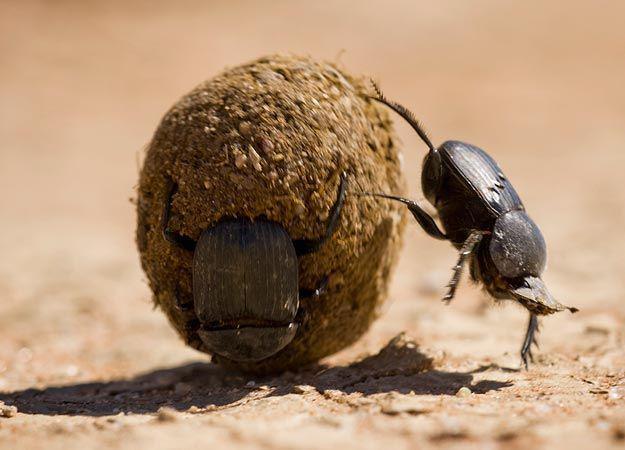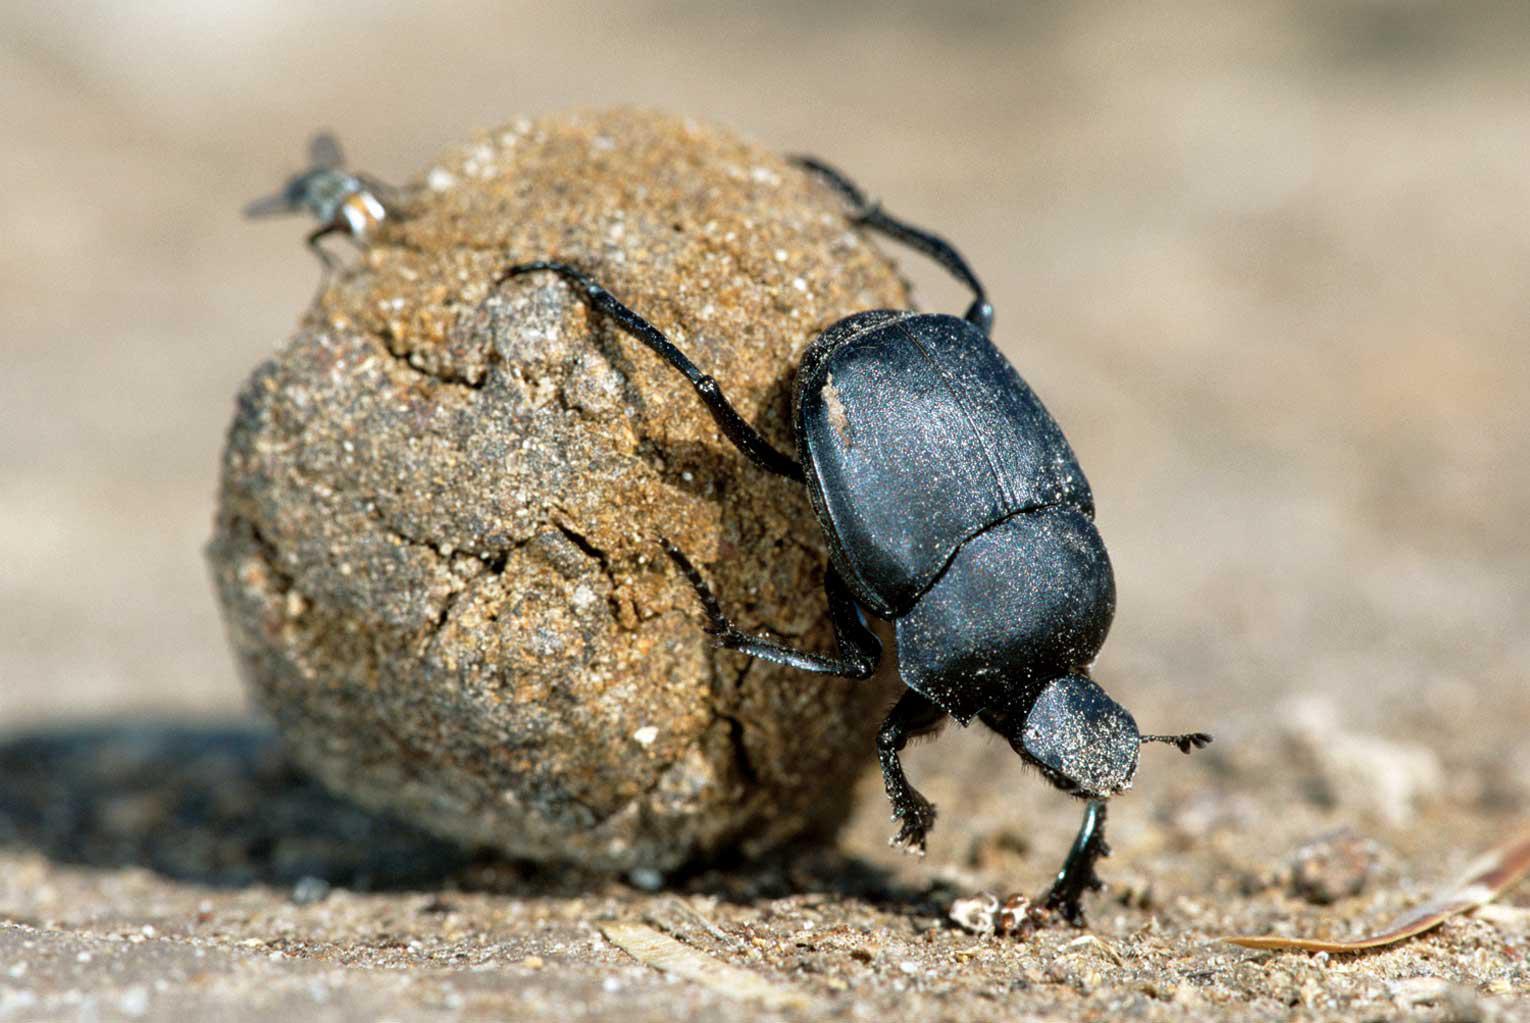The first image is the image on the left, the second image is the image on the right. For the images shown, is this caption "Exactly one black beetle is shown in each image with its back appendages on a round rocky particle and at least one front appendage on the ground." true? Answer yes or no. Yes. The first image is the image on the left, the second image is the image on the right. Examine the images to the left and right. Is the description "Each image shows exactly one beetle in contact with one round dung ball." accurate? Answer yes or no. Yes. 